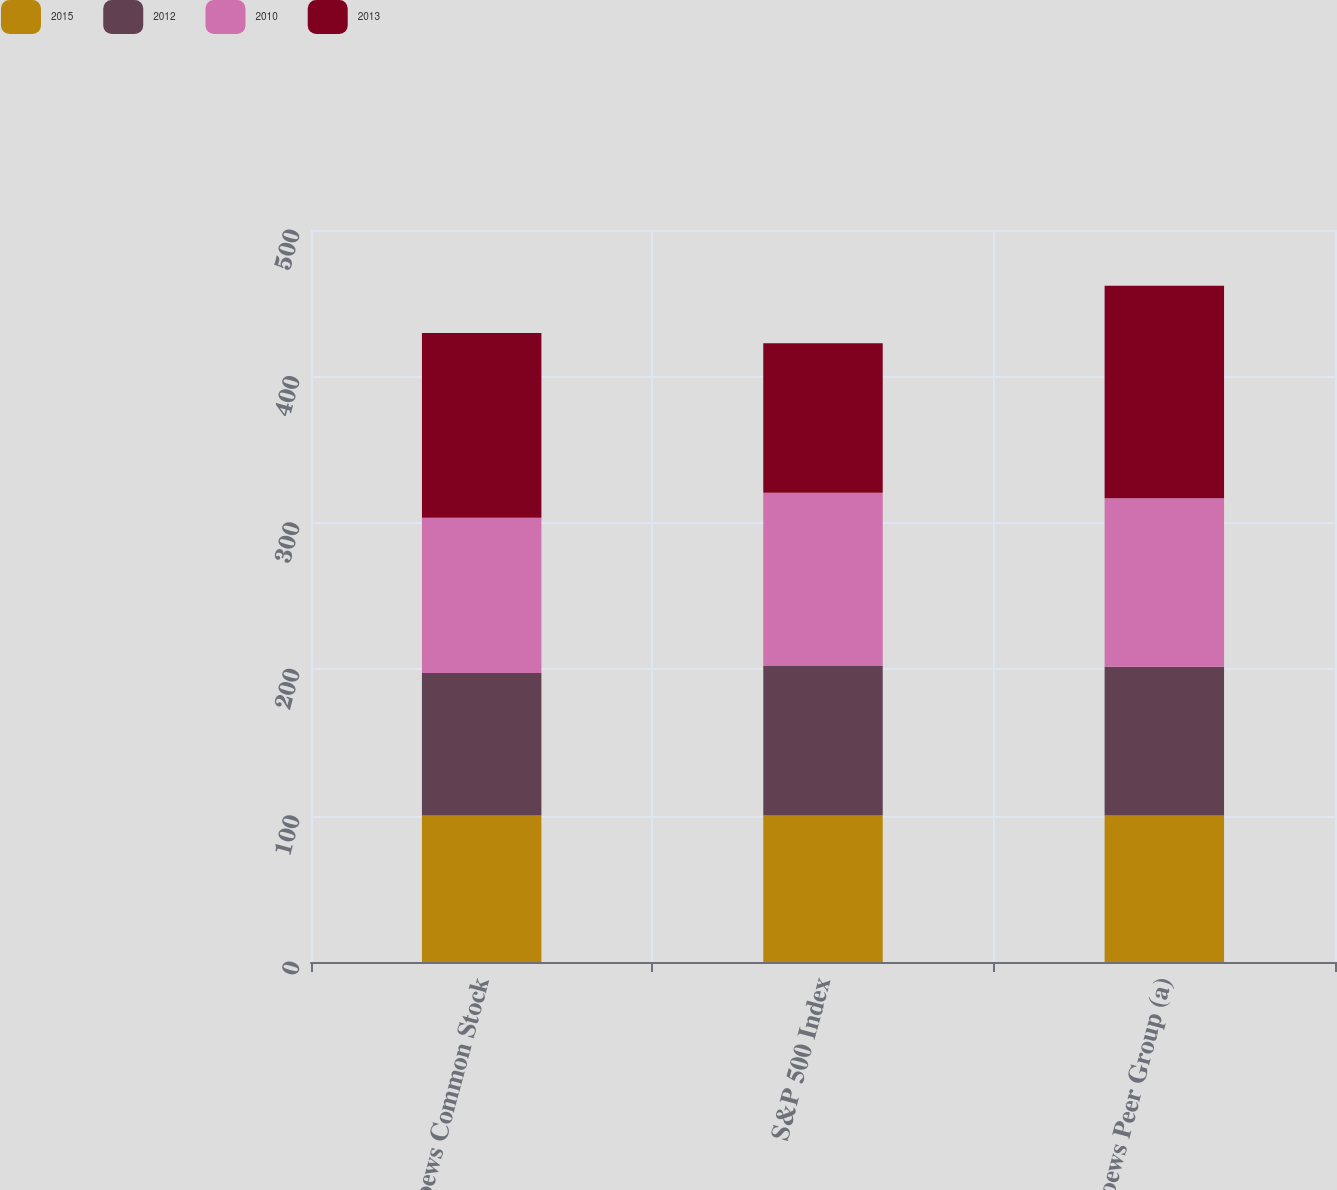<chart> <loc_0><loc_0><loc_500><loc_500><stacked_bar_chart><ecel><fcel>Loews Common Stock<fcel>S&P 500 Index<fcel>Loews Peer Group (a)<nl><fcel>2015<fcel>100<fcel>100<fcel>100<nl><fcel>2012<fcel>97.37<fcel>102.11<fcel>101.59<nl><fcel>2010<fcel>106.04<fcel>118.45<fcel>115.19<nl><fcel>2013<fcel>126.23<fcel>102.11<fcel>145.12<nl></chart> 